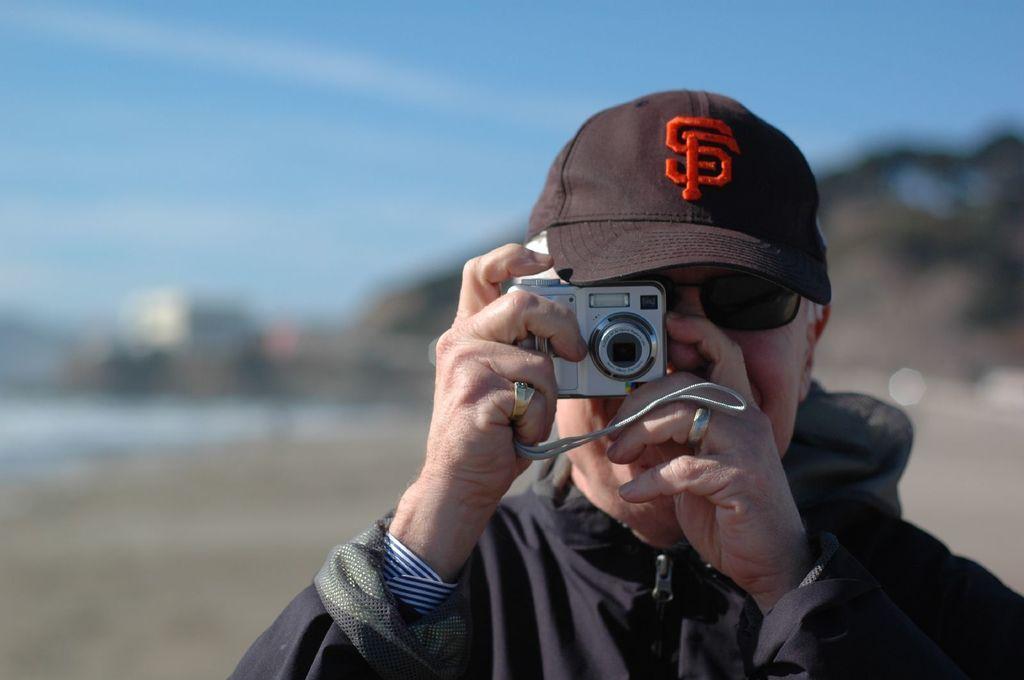Please provide a concise description of this image. in this image the person is holding the camera and person is wearing the black shirt and black hat and spex and the background is sunny. 